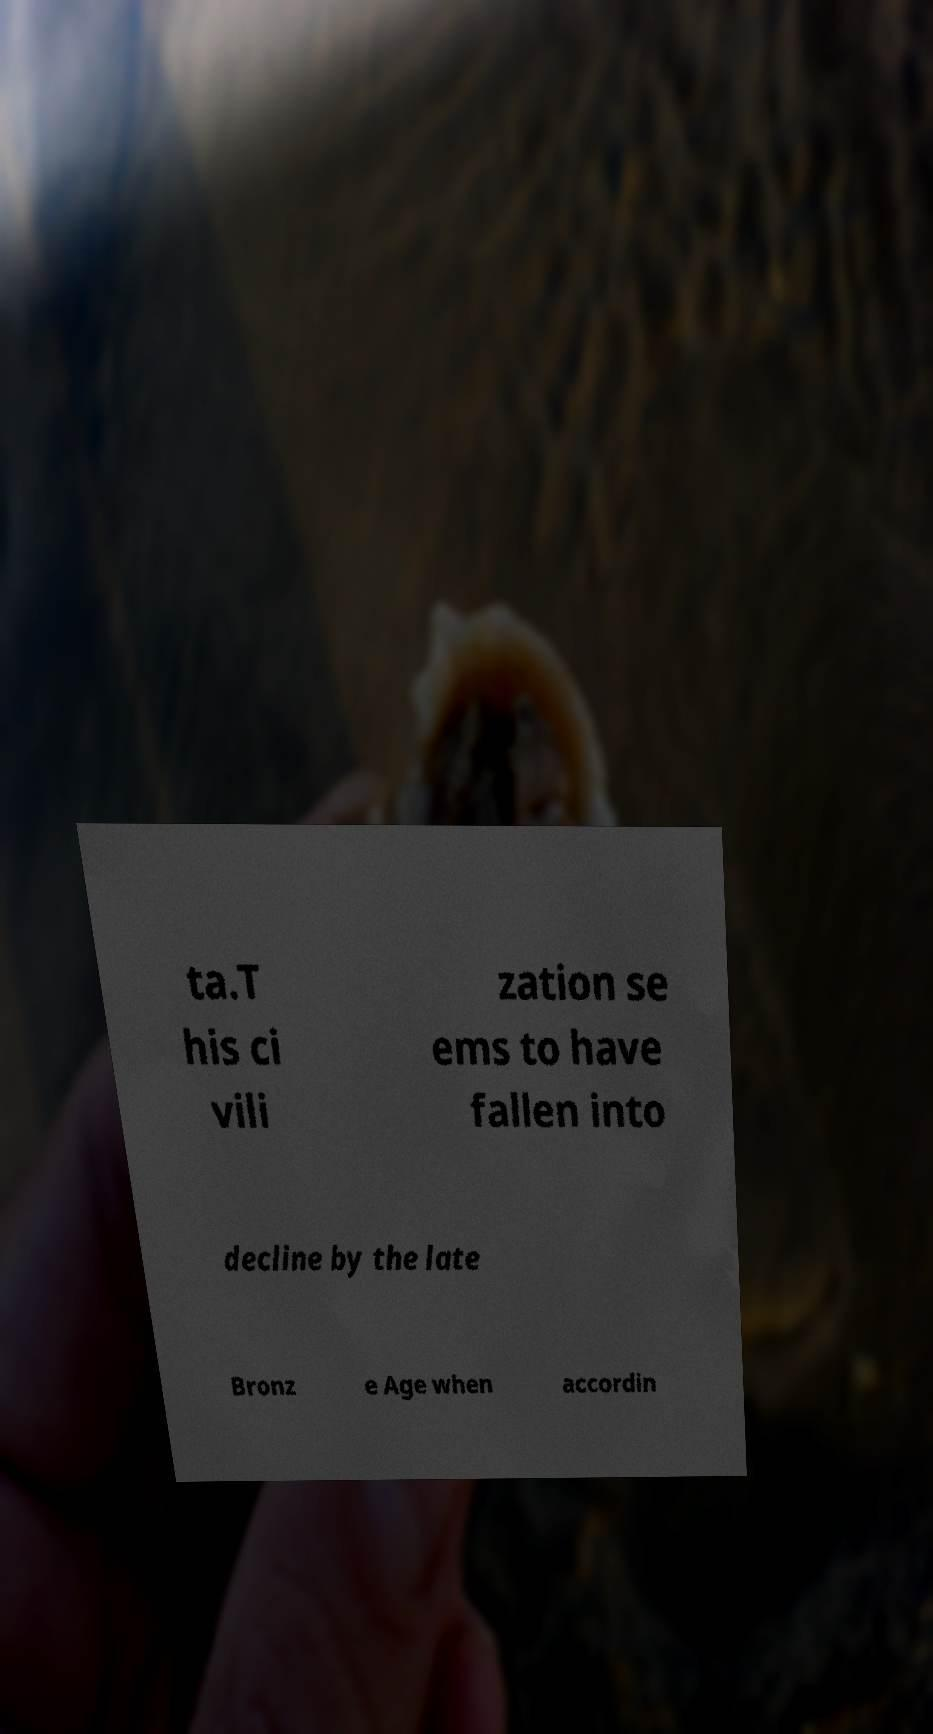Please read and relay the text visible in this image. What does it say? ta.T his ci vili zation se ems to have fallen into decline by the late Bronz e Age when accordin 